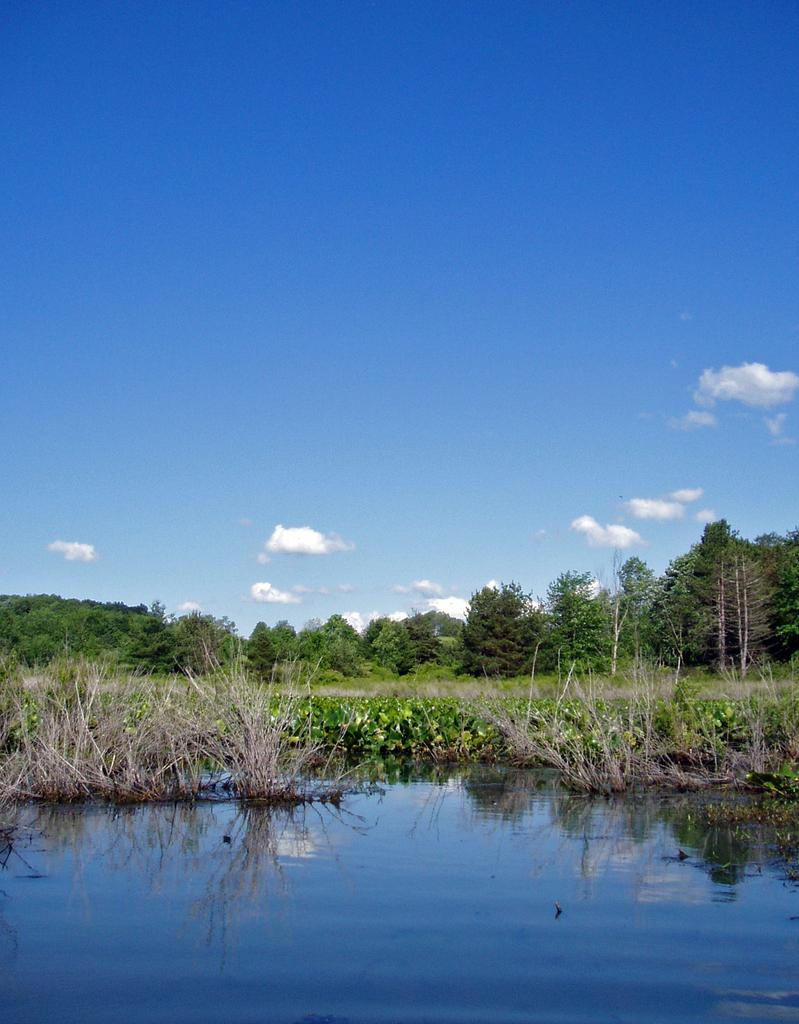What type of vegetation can be seen in the image? There are trees and plants in the image. What body of water is visible at the bottom of the image? There is a lake at the bottom of the image. What part of the natural environment is visible at the top of the image? The sky is visible at the top of the image. Are there any desks visible in the image? No, there are no desks present in the image. What time of day is depicted in the image? The provided facts do not mention the time of day, so it cannot be determined from the image. 